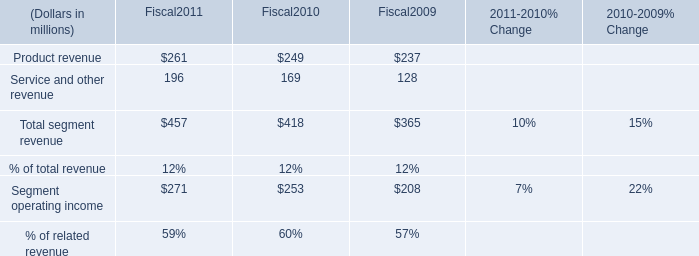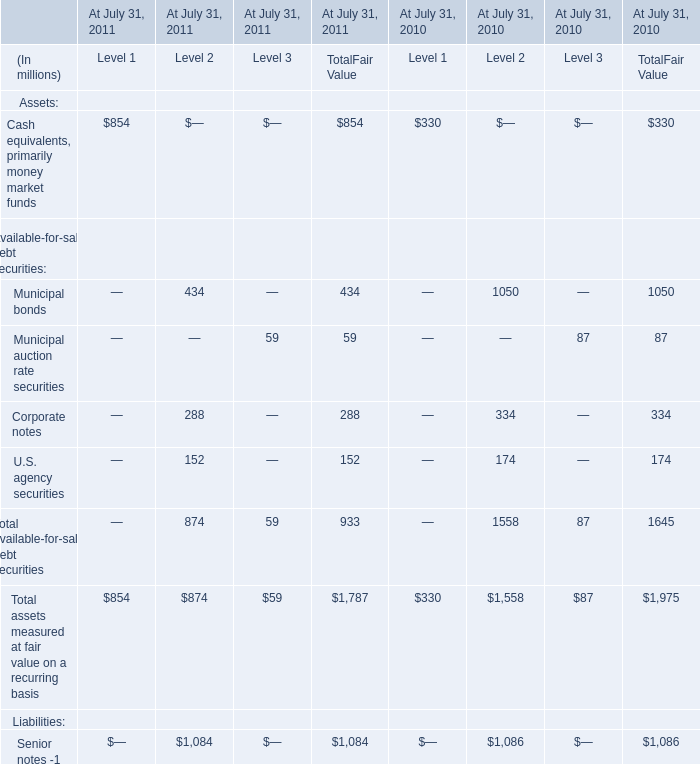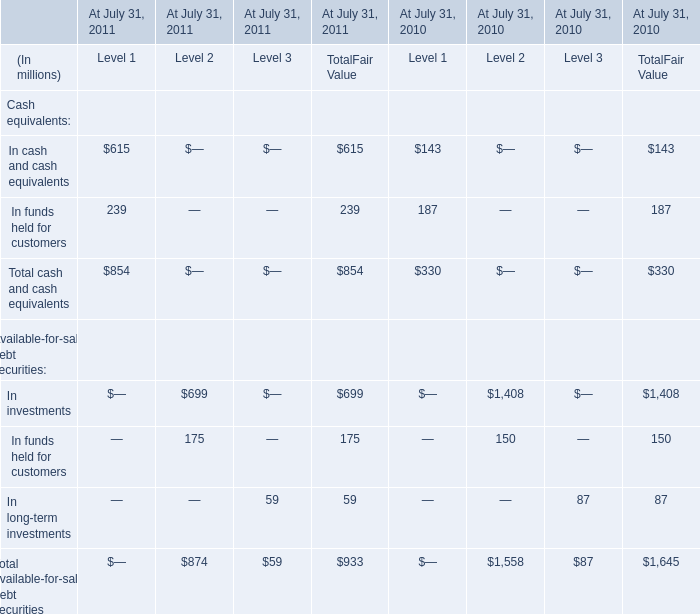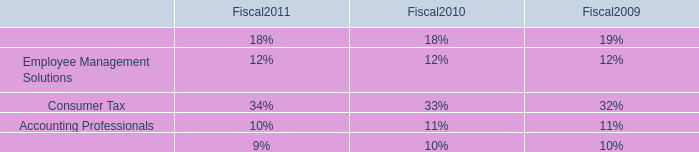What is the sum of elements for TotalFair Value in the range of 1 and 300 in 2011? (in million) 
Computations: ((59 + 288) + 152)
Answer: 499.0. 